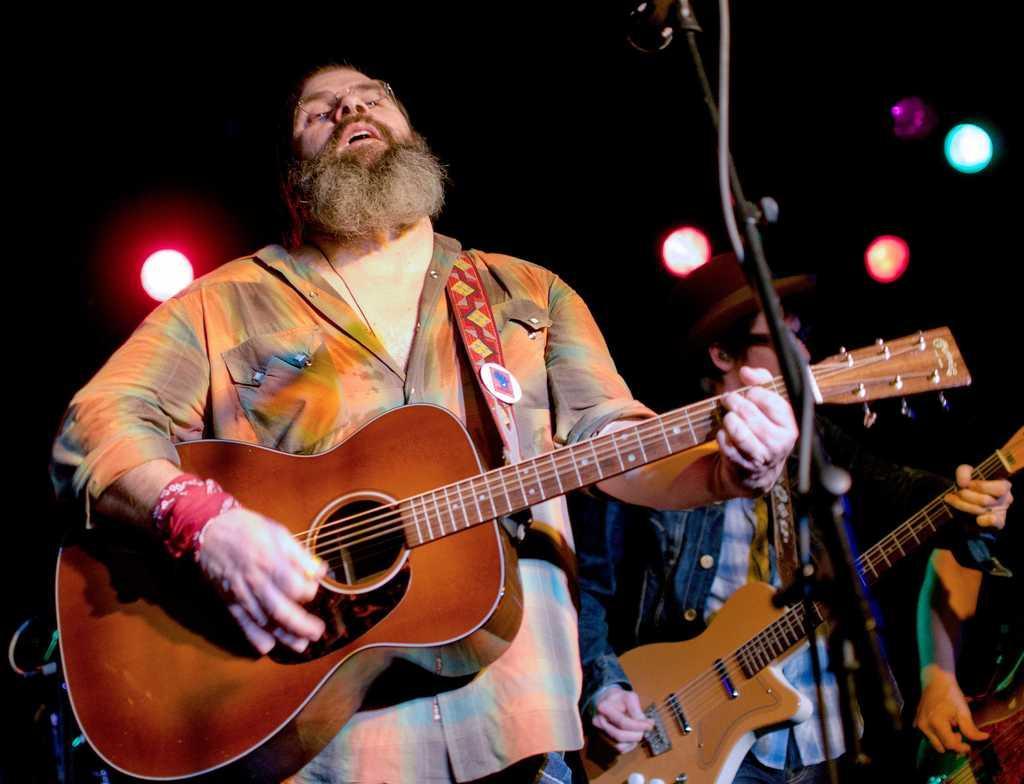Describe this image in one or two sentences. In this image there is a person playing a guitar and at the right side of the image there is an another person also playing a guitar. 